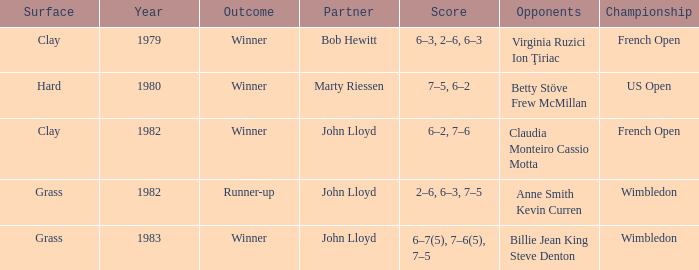Who were the opponents that led to an outcome of winner on a grass surface? Billie Jean King Steve Denton. 